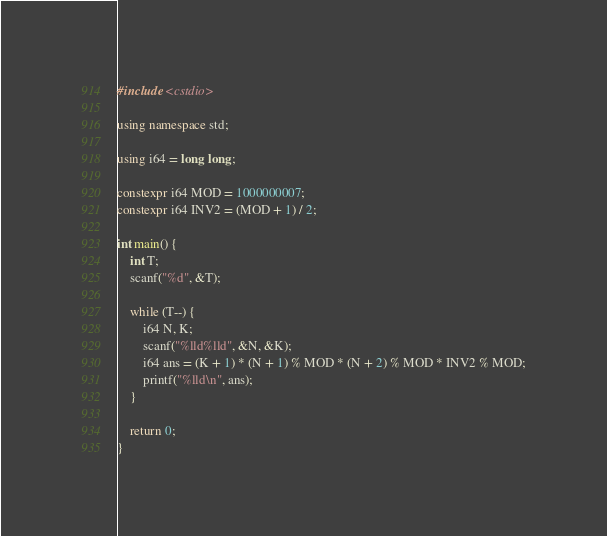<code> <loc_0><loc_0><loc_500><loc_500><_C++_>#include <cstdio>

using namespace std;

using i64 = long long;

constexpr i64 MOD = 1000000007;
constexpr i64 INV2 = (MOD + 1) / 2;

int main() {
	int T;
	scanf("%d", &T);

	while (T--) {
		i64 N, K;
		scanf("%lld%lld", &N, &K);
		i64 ans = (K + 1) * (N + 1) % MOD * (N + 2) % MOD * INV2 % MOD;
		printf("%lld\n", ans);
	}

	return 0;
}
</code> 